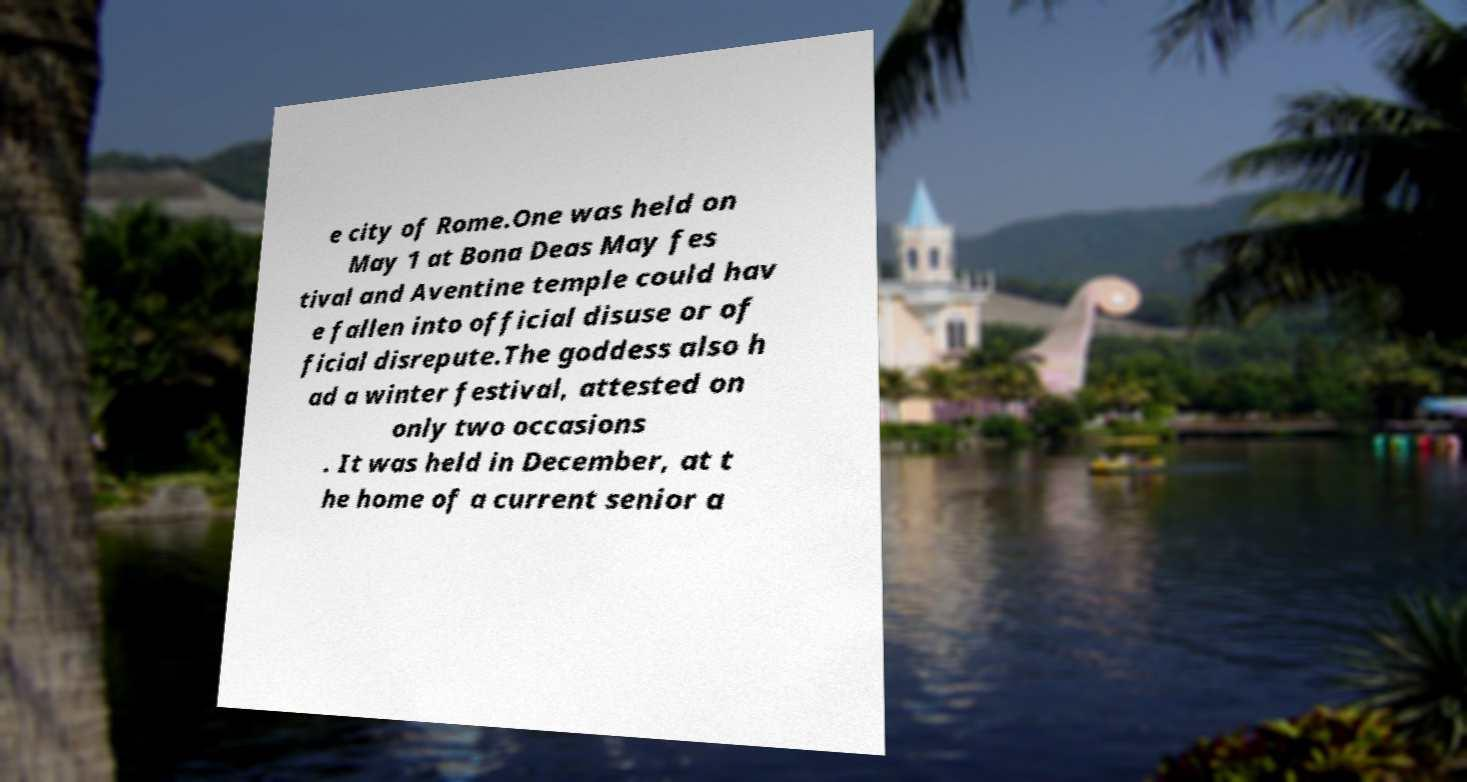I need the written content from this picture converted into text. Can you do that? e city of Rome.One was held on May 1 at Bona Deas May fes tival and Aventine temple could hav e fallen into official disuse or of ficial disrepute.The goddess also h ad a winter festival, attested on only two occasions . It was held in December, at t he home of a current senior a 